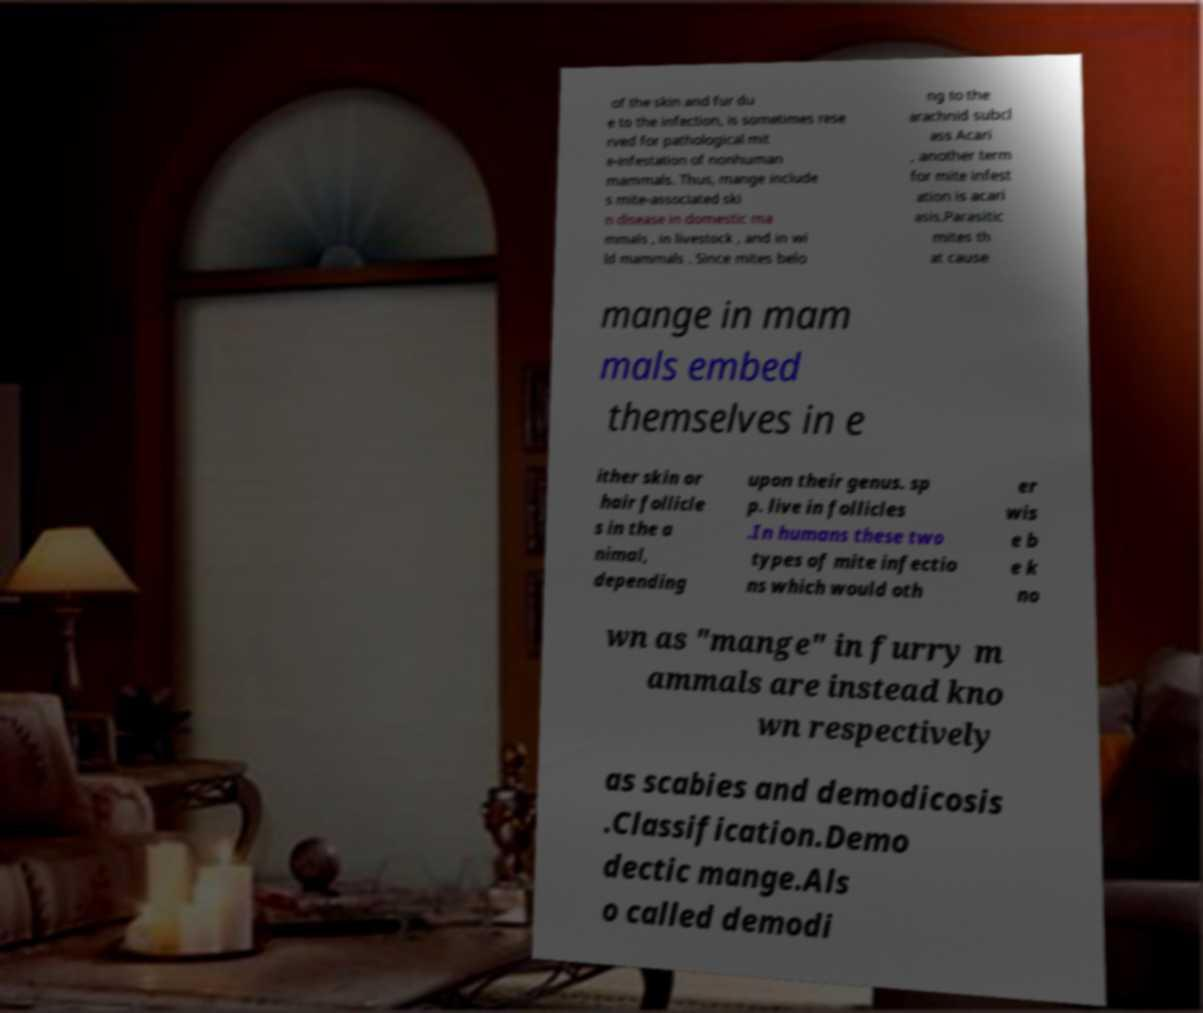There's text embedded in this image that I need extracted. Can you transcribe it verbatim? of the skin and fur du e to the infection, is sometimes rese rved for pathological mit e-infestation of nonhuman mammals. Thus, mange include s mite-associated ski n disease in domestic ma mmals , in livestock , and in wi ld mammals . Since mites belo ng to the arachnid subcl ass Acari , another term for mite infest ation is acari asis.Parasitic mites th at cause mange in mam mals embed themselves in e ither skin or hair follicle s in the a nimal, depending upon their genus. sp p. live in follicles .In humans these two types of mite infectio ns which would oth er wis e b e k no wn as "mange" in furry m ammals are instead kno wn respectively as scabies and demodicosis .Classification.Demo dectic mange.Als o called demodi 